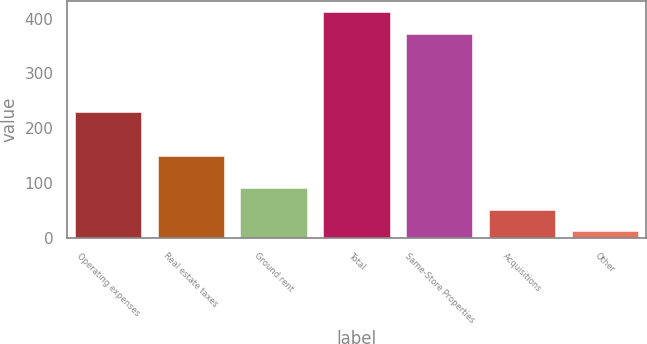<chart> <loc_0><loc_0><loc_500><loc_500><bar_chart><fcel>Operating expenses<fcel>Real estate taxes<fcel>Ground rent<fcel>Total<fcel>Same-Store Properties<fcel>Acquisitions<fcel>Other<nl><fcel>229.3<fcel>148.8<fcel>91.54<fcel>412.32<fcel>372.6<fcel>51.82<fcel>12.1<nl></chart> 